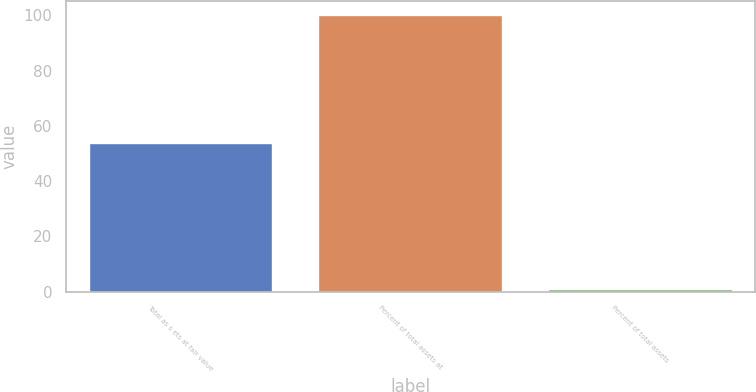<chart> <loc_0><loc_0><loc_500><loc_500><bar_chart><fcel>Total as s ets at fair value<fcel>Percent of total assets at<fcel>Percent of total assets<nl><fcel>53.8<fcel>100<fcel>0.8<nl></chart> 